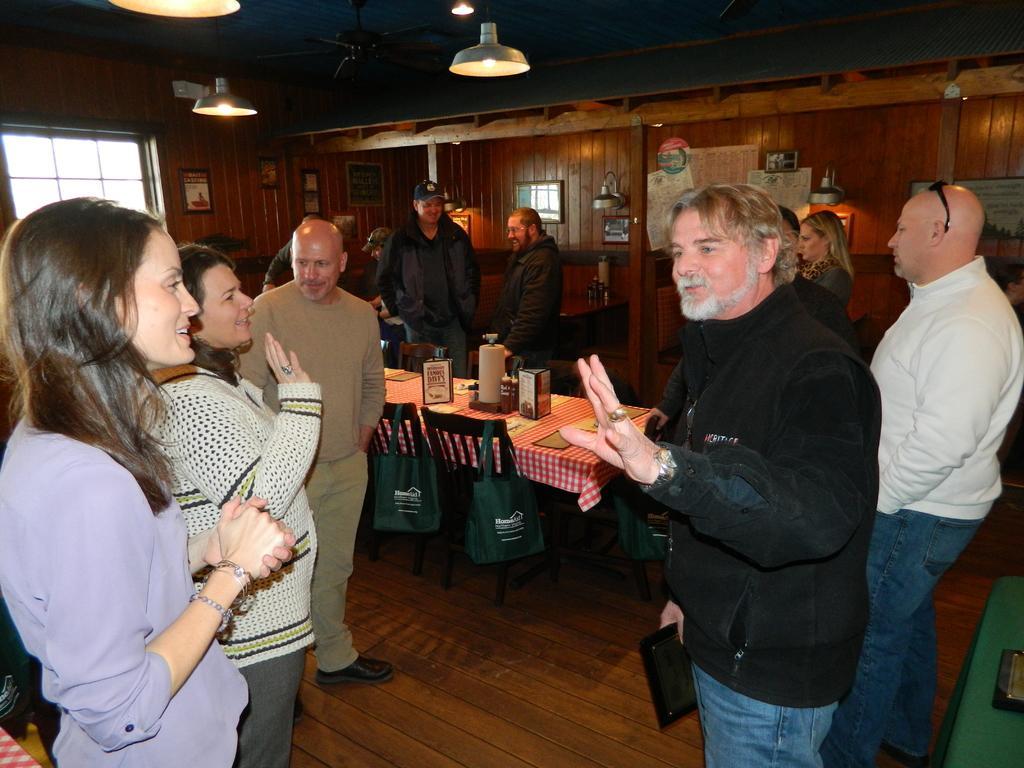Can you describe this image briefly? In the image there are few people standing. In between them there is a table with bottles, packets and some other things. There are bags hanging on the chairs. In the background there is a wall with frames, window and some other objects. At the top of the image there is ceiling with lights. 